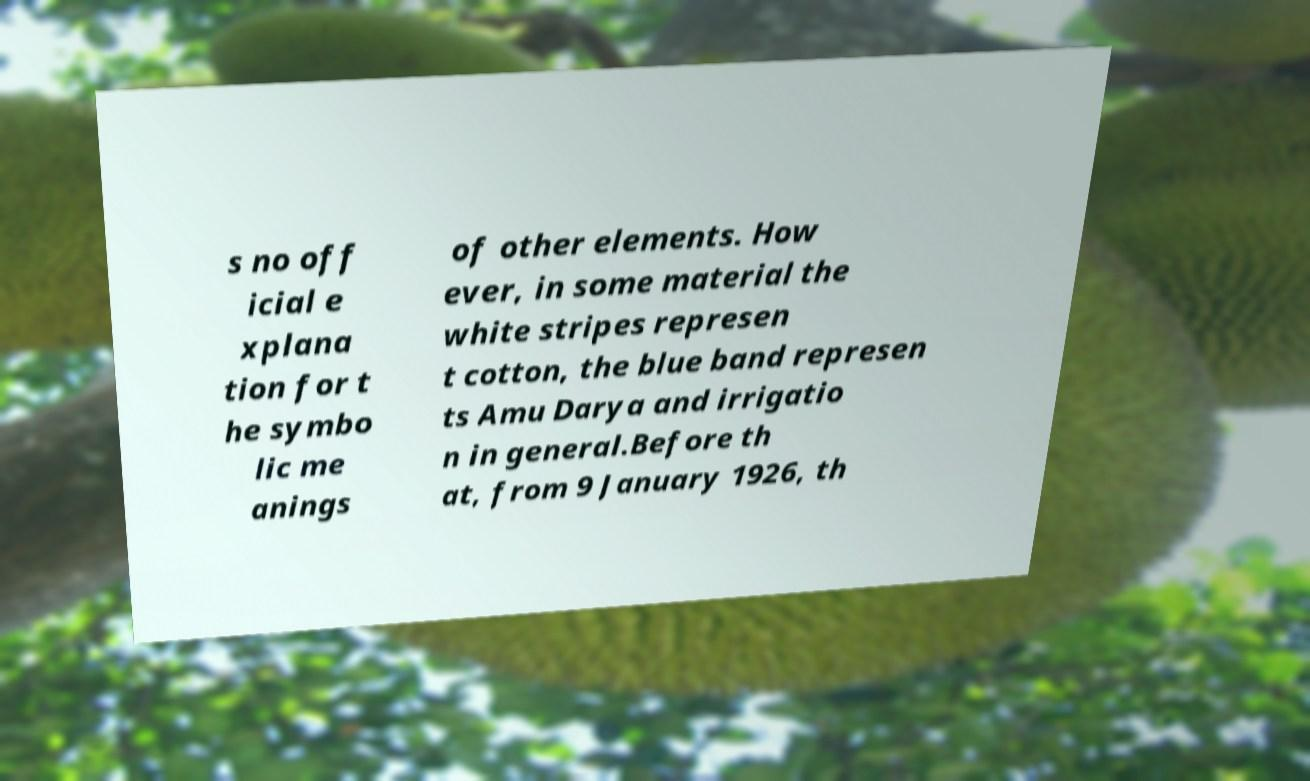For documentation purposes, I need the text within this image transcribed. Could you provide that? s no off icial e xplana tion for t he symbo lic me anings of other elements. How ever, in some material the white stripes represen t cotton, the blue band represen ts Amu Darya and irrigatio n in general.Before th at, from 9 January 1926, th 